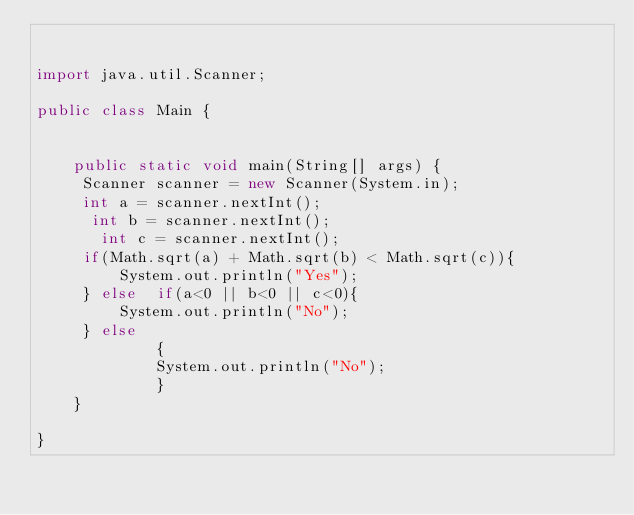<code> <loc_0><loc_0><loc_500><loc_500><_Java_>

import java.util.Scanner;

public class Main {

    
    public static void main(String[] args) {
     Scanner scanner = new Scanner(System.in);
     int a = scanner.nextInt();
      int b = scanner.nextInt();
       int c = scanner.nextInt();
     if(Math.sqrt(a) + Math.sqrt(b) < Math.sqrt(c)){
         System.out.println("Yes");
     } else  if(a<0 || b<0 || c<0){
         System.out.println("No");
     } else 
             {
             System.out.println("No");
             }
    }
    
}
</code> 